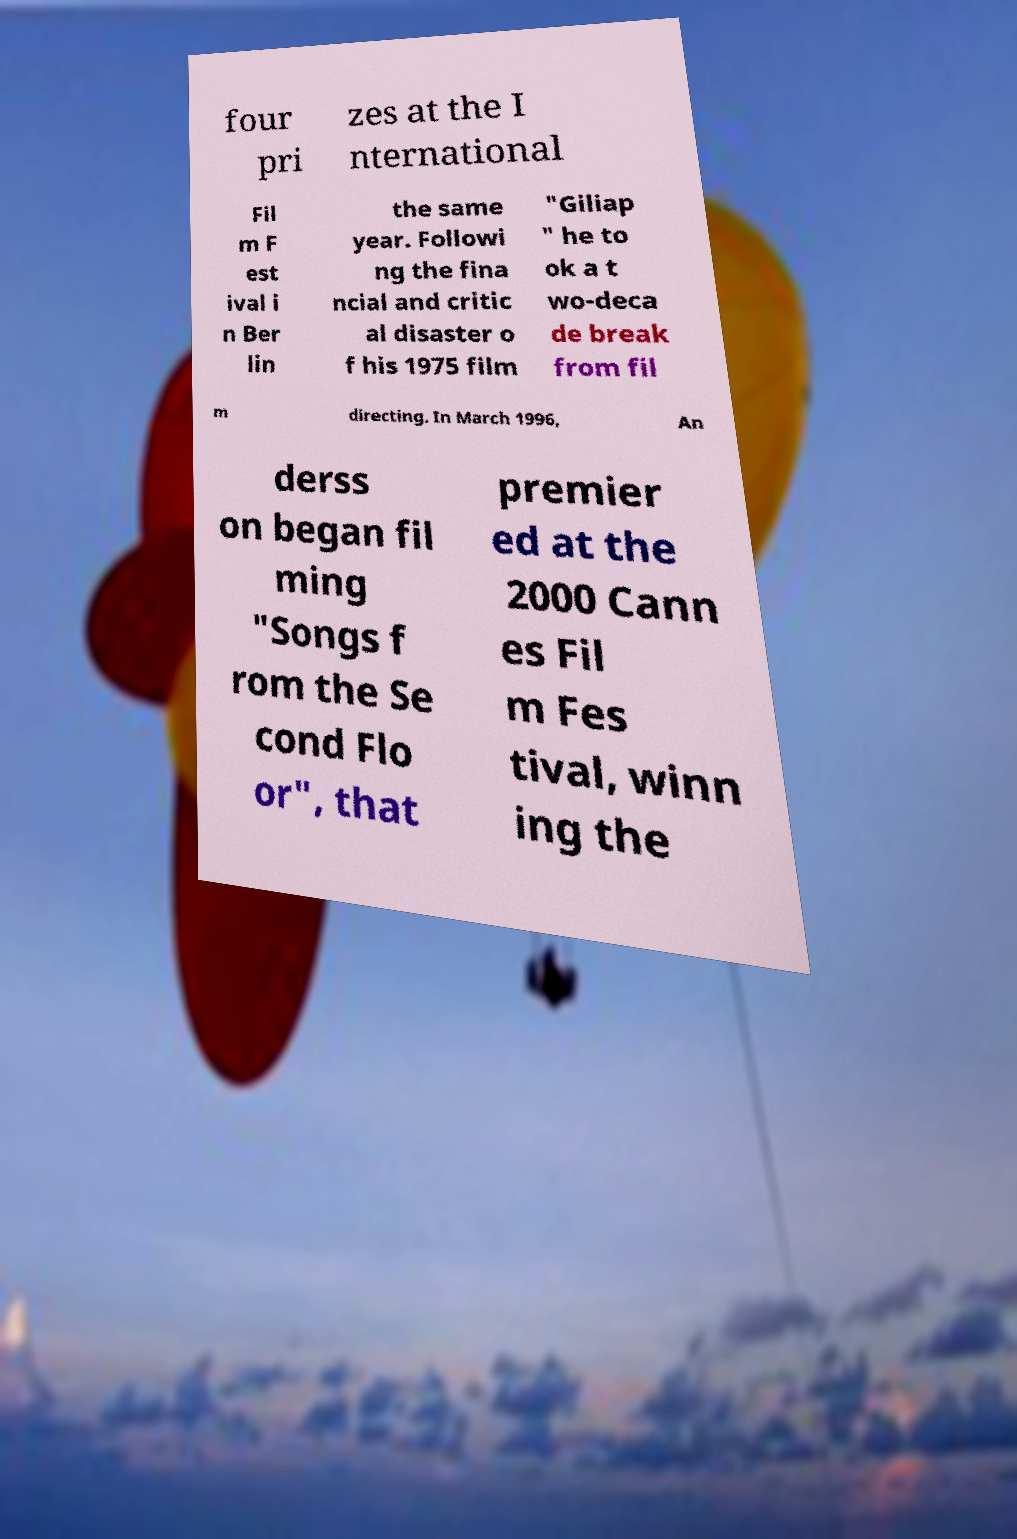Can you accurately transcribe the text from the provided image for me? four pri zes at the I nternational Fil m F est ival i n Ber lin the same year. Followi ng the fina ncial and critic al disaster o f his 1975 film "Giliap " he to ok a t wo-deca de break from fil m directing. In March 1996, An derss on began fil ming "Songs f rom the Se cond Flo or", that premier ed at the 2000 Cann es Fil m Fes tival, winn ing the 